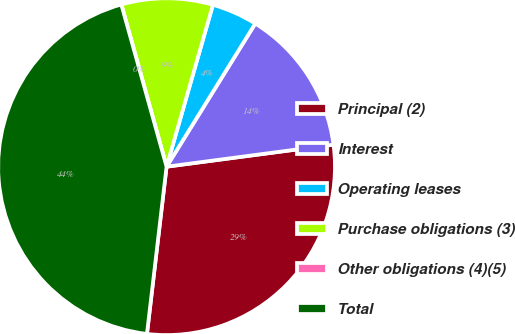Convert chart to OTSL. <chart><loc_0><loc_0><loc_500><loc_500><pie_chart><fcel>Principal (2)<fcel>Interest<fcel>Operating leases<fcel>Purchase obligations (3)<fcel>Other obligations (4)(5)<fcel>Total<nl><fcel>28.95%<fcel>14.08%<fcel>4.39%<fcel>8.77%<fcel>0.0%<fcel>43.81%<nl></chart> 